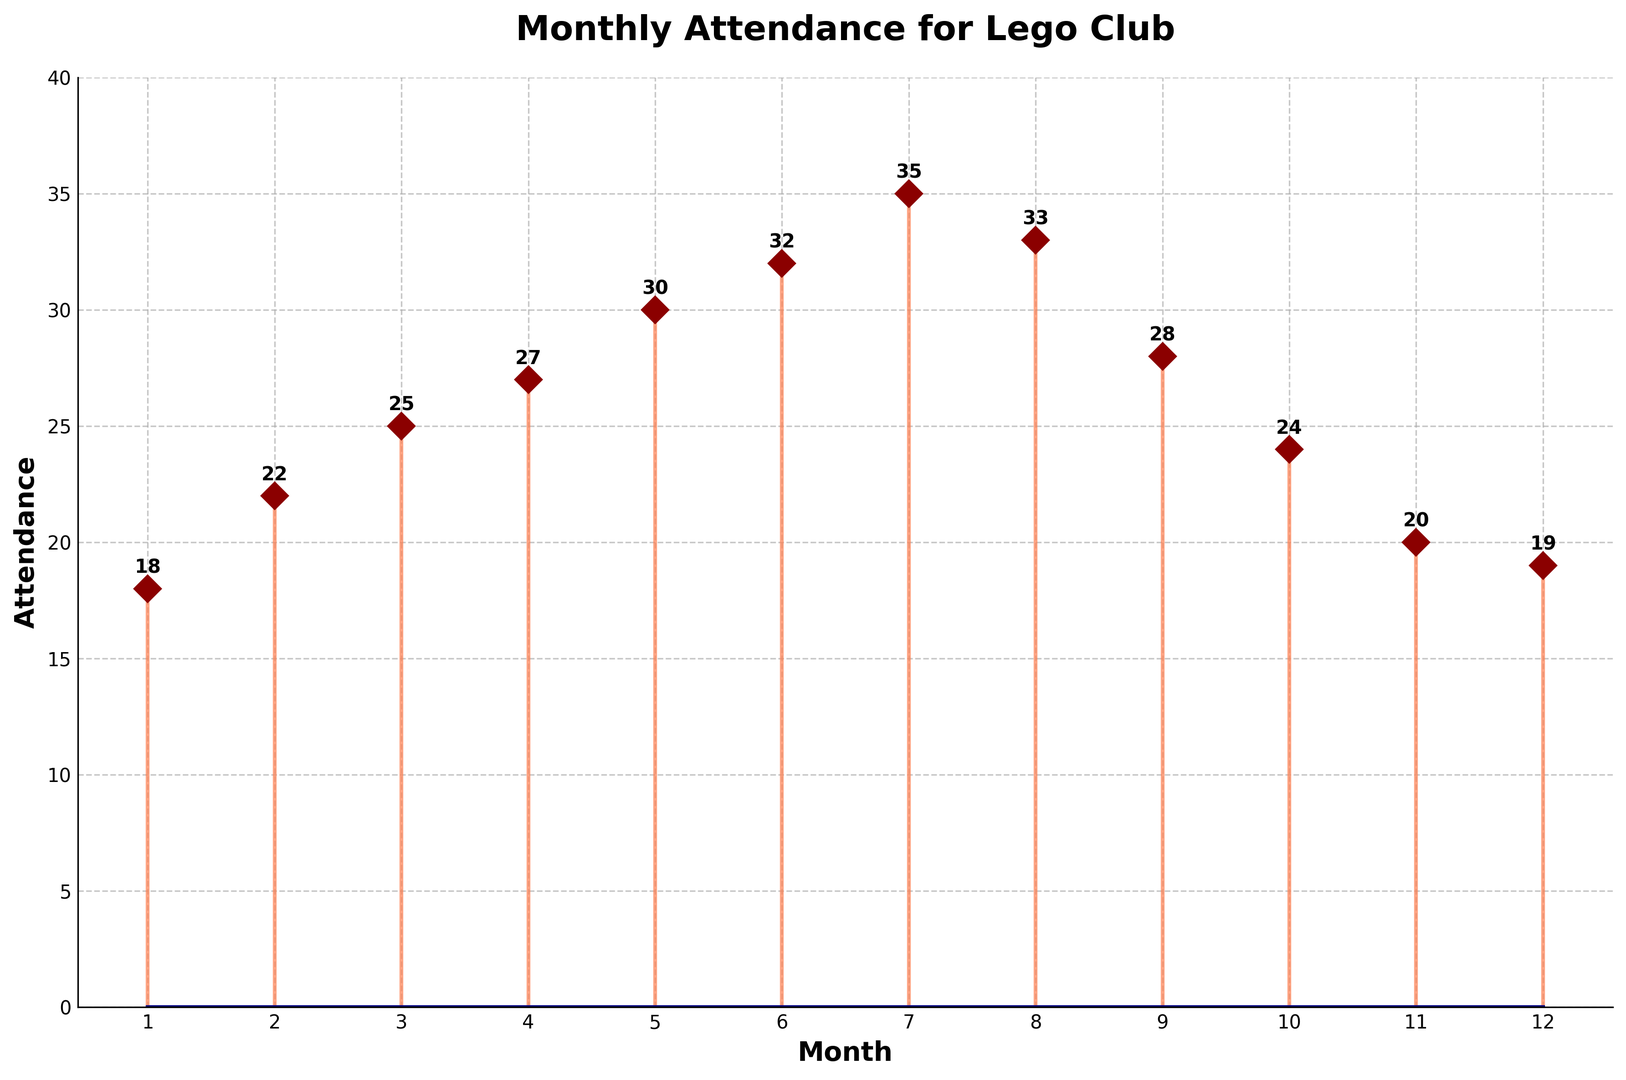Which month had the highest attendance? The highest point on the stem plot is in July, which had 35 attendees.
Answer: July Which month had the lowest attendance? The lowest point on the stem plot is in January, which had 18 attendees.
Answer: January What is the average attendance over the year? Sum all the attendance values (18 + 22 + 25 + 27 + 30 + 32 + 35 + 33 + 28 + 24 + 20 + 19 = 313) and divide by the number of months (12). The average is 313/12, which is approximately 26.08.
Answer: ~26.08 How much did attendance increase from January to July? In January, attendance was 18. In July, it was 35. The increase is 35 - 18 = 17.
Answer: 17 In which months did attendance decrease compared to the previous month? Compare month-to-month values: Attendance decreased from August to September (33 to 28), from October to November (24 to 20), and from November to December (20 to 19).
Answer: September, November, December What was the total attendance for the first half of the year (January to June)? Sum the attendance values for the first half of the year (18 + 22 + 25 + 27 + 30 + 32 = 154).
Answer: 154 What is the most noticeable trend in attendance throughout the year? Visually, the attendance increases gradually from January to July and then gradually decreases for the rest of the year.
Answer: Increase then decrease Between which two consecutive months was the biggest increase in attendance? The largest increase in attendance is between June (32) and July (35), which is an increase of 3 attendees.
Answer: June to July What is the range of the attendance values over the year? The range is the difference between the highest value (35 in July) and the lowest value (18 in January), which is 35 - 18 = 17.
Answer: 17 How many months had an attendance greater than or equal to 30? The attendance values greater than or equal to 30 are in May (30), June (32), July (35), and August (33), making a total of 4 months.
Answer: 4 